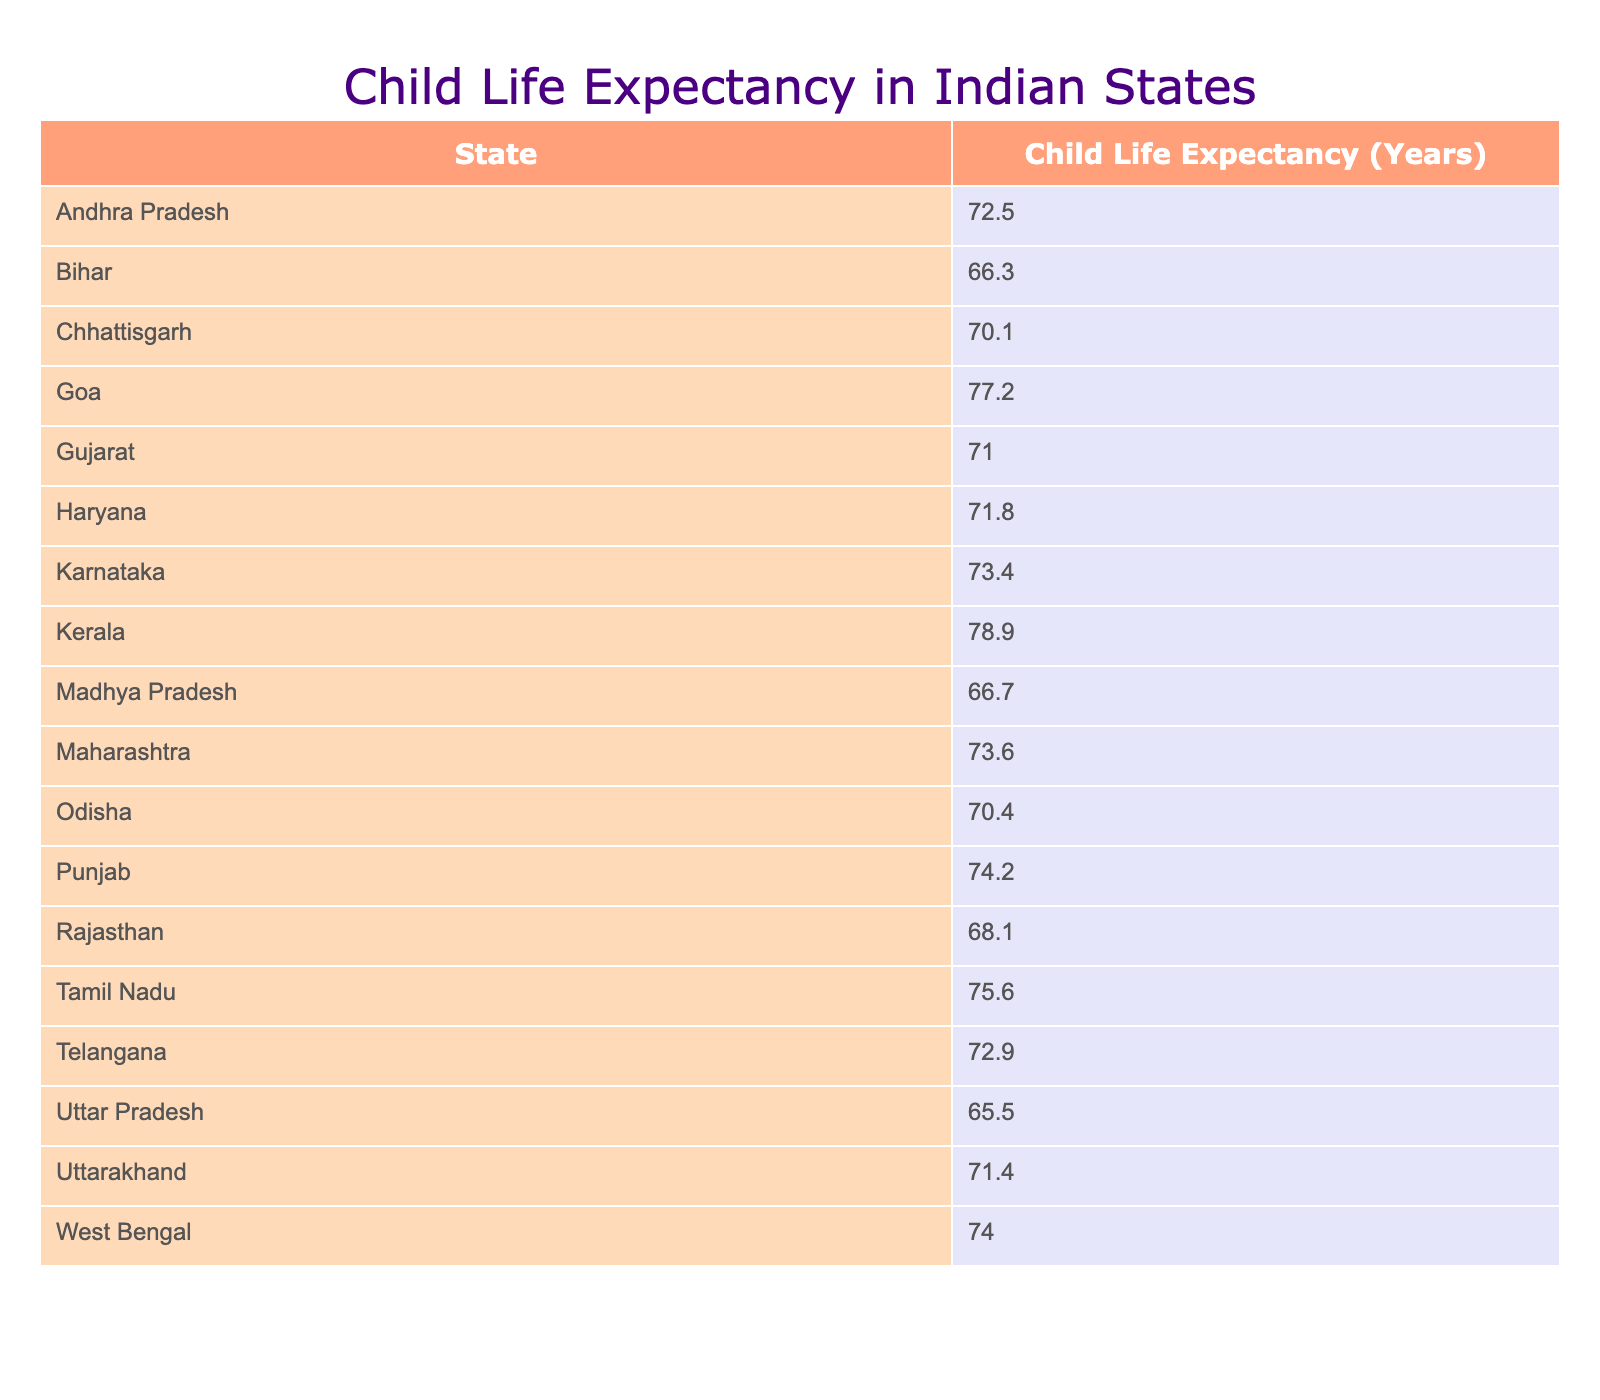What is the child life expectancy in Kerala? According to the table, Kerala has a child life expectancy of 78.9 years. You can find this value directly in the row corresponding to Kerala.
Answer: 78.9 Which state has the lowest child life expectancy? The state with the lowest child life expectancy is Uttar Pradesh with a value of 65.5 years. This can be determined by scanning through the table to find the minimum value in the "Child Life Expectancy (Years)" column.
Answer: Uttar Pradesh What is the average child life expectancy of the top three states? The top three states based on child life expectancy are Kerala (78.9), Goa (77.2), and Tamil Nadu (75.6). Adding these values gives 78.9 + 77.2 + 75.6 = 231.7. Dividing by 3, the average is 231.7 / 3 = 77.23.
Answer: 77.23 Is the child life expectancy in Bihar higher than that in Rajasthan? Bihar has a child life expectancy of 66.3 years, while Rajasthan's is 68.1 years. Since 66.3 is less than 68.1, the statement is false.
Answer: No If the child life expectancy in Gujarat were to increase by 5 years, what would it be? Gujarat has a child life expectancy of 71.0 years. If this were to increase by 5 years, we would add 5 to 71.0, resulting in 71.0 + 5 = 76.0 years.
Answer: 76.0 How many states have a child life expectancy greater than 75 years? From the table, the states that have a child life expectancy greater than 75 years are Kerala, Goa, and Tamil Nadu, totaling three states.
Answer: 3 What is the difference in child life expectancy between Haryana and Telangana? Haryana has a child life expectancy of 71.8 years, while Telangana's is 72.9 years. To find the difference, we subtract Haryana's value from Telangana's: 72.9 - 71.8 = 1.1 years.
Answer: 1.1 Which state has a higher child life expectancy: Maharashtra or Karnataka? Maharashtra has a child life expectancy of 73.6 years, whereas Karnataka has 73.4 years. Comparing these values, 73.6 is greater than 73.4, indicating that Maharashtra has a higher expectancy.
Answer: Maharashtra What is the median child life expectancy among all the states listed? To determine the median, first, we need to sort the child life expectancy values in order. After sorting, there are 20 states, and the median will be the average of the 10th and 11th values in the ordered list. The 10th and 11th values are 71.4 and 72.5. The average is (71.4 + 72.5) / 2 = 71.95.
Answer: 71.95 